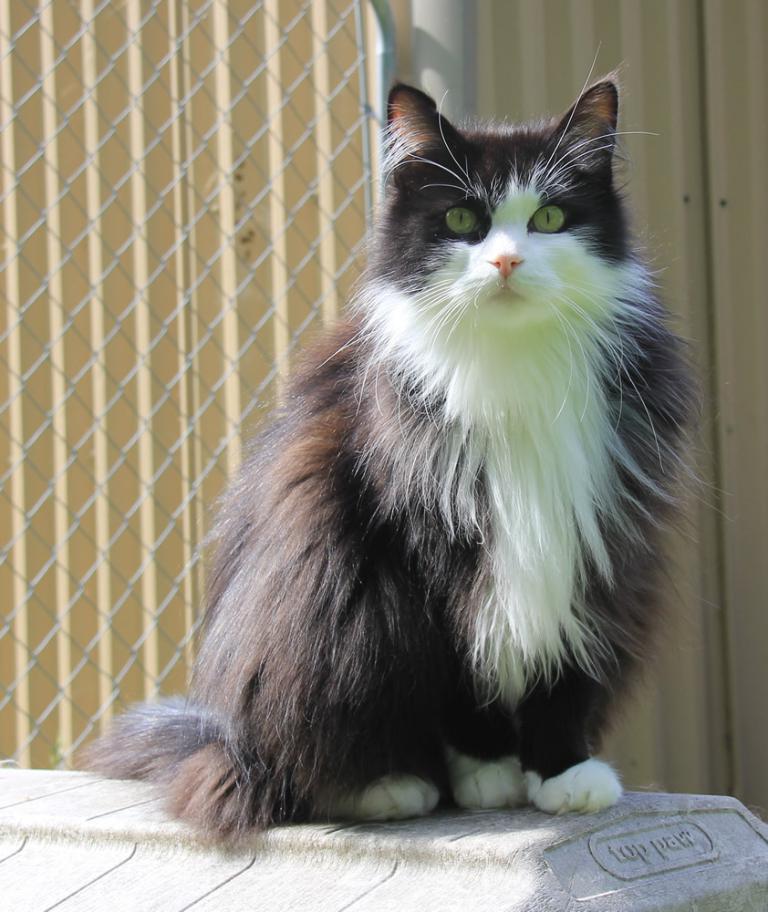Describe this image in one or two sentences. In this image there is a cat sitting on a wall. There is text on the wall. Behind it there is a fence. 